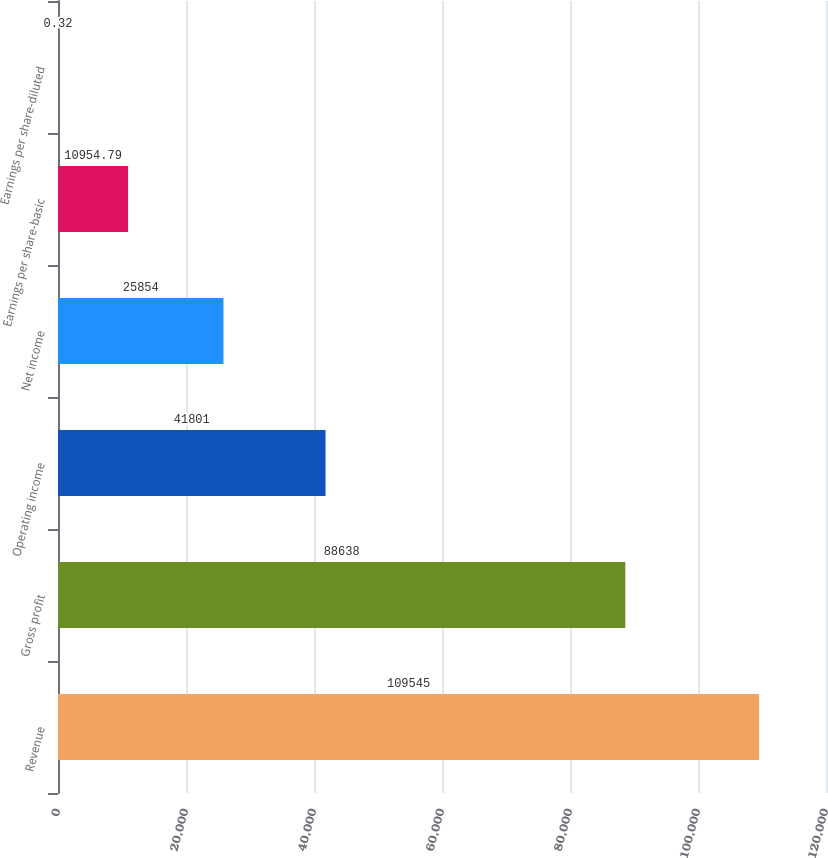Convert chart. <chart><loc_0><loc_0><loc_500><loc_500><bar_chart><fcel>Revenue<fcel>Gross profit<fcel>Operating income<fcel>Net income<fcel>Earnings per share-basic<fcel>Earnings per share-diluted<nl><fcel>109545<fcel>88638<fcel>41801<fcel>25854<fcel>10954.8<fcel>0.32<nl></chart> 